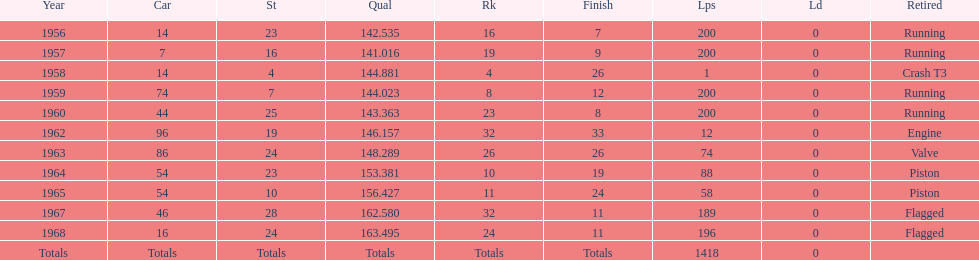What year did he have the same number car as 1964? 1965. 